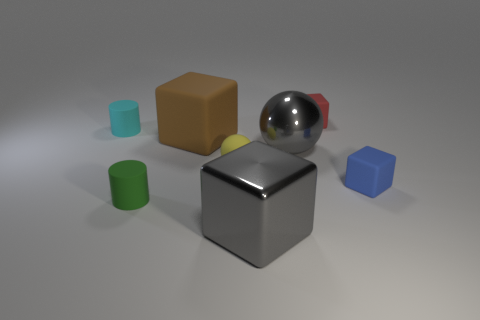The red thing is what size?
Provide a succinct answer. Small. There is a tiny red matte thing; what shape is it?
Provide a succinct answer. Cube. Is there anything else that is the same shape as the brown object?
Your answer should be very brief. Yes. Are there fewer big gray things in front of the big ball than yellow things?
Offer a terse response. No. There is a big metal block that is in front of the small green rubber cylinder; is it the same color as the tiny matte ball?
Your response must be concise. No. What number of rubber objects are either small green things or big blocks?
Your answer should be very brief. 2. Is there any other thing that is the same size as the rubber sphere?
Ensure brevity in your answer.  Yes. What is the color of the large cube that is the same material as the small green cylinder?
Provide a succinct answer. Brown. How many blocks are blue matte things or red objects?
Your response must be concise. 2. How many objects are big blocks or gray objects behind the metallic cube?
Ensure brevity in your answer.  3. 